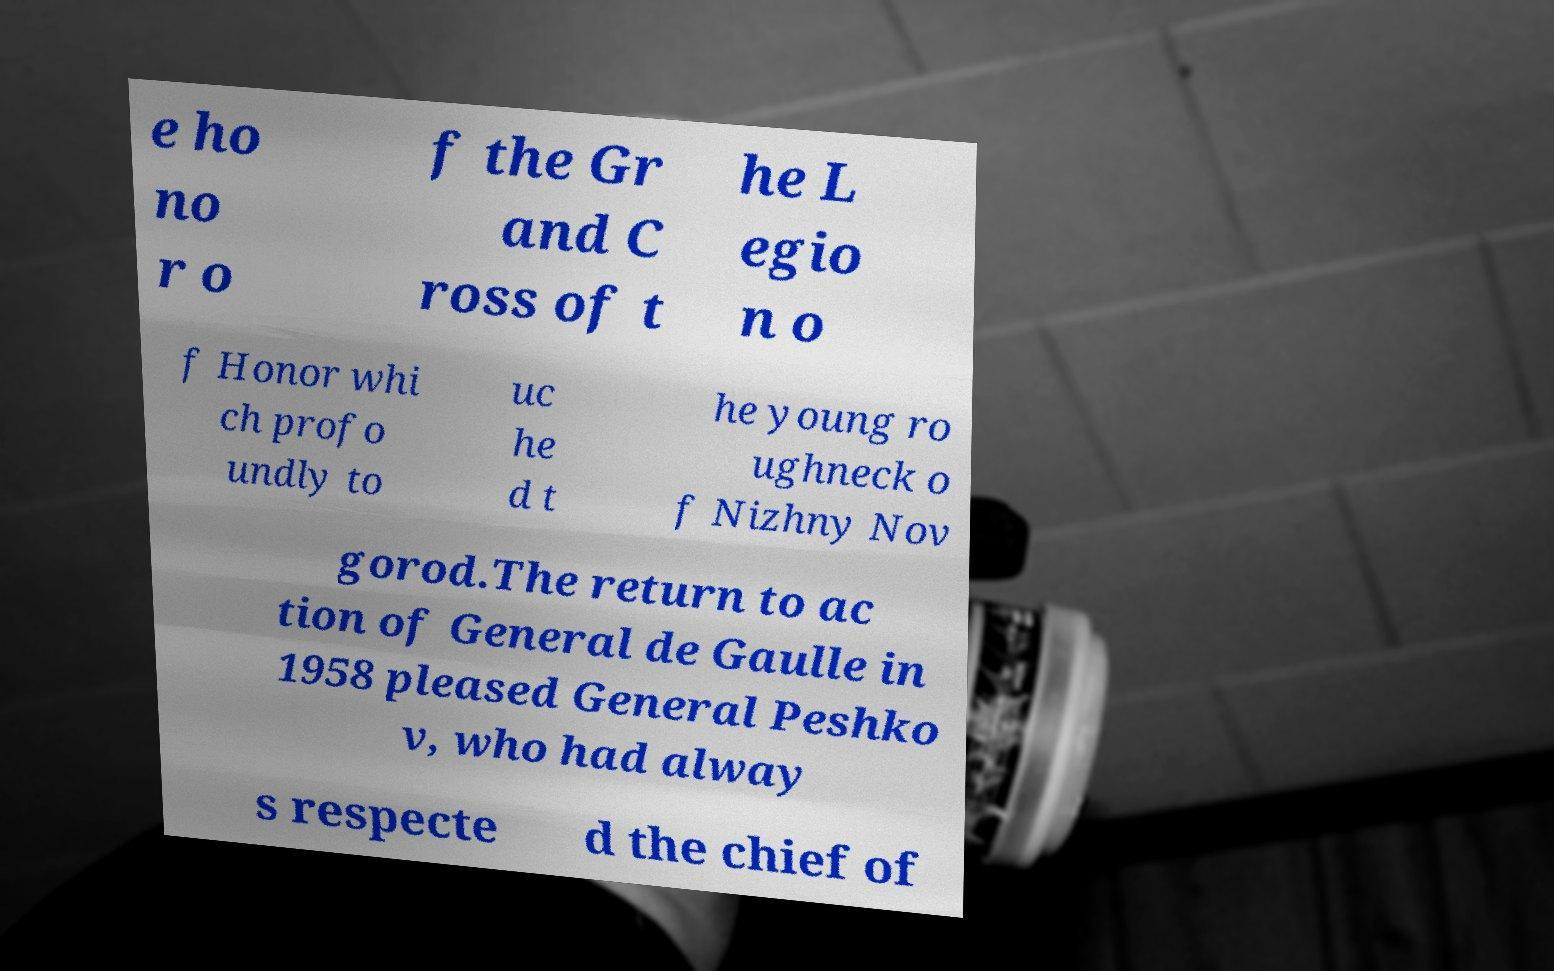Please identify and transcribe the text found in this image. e ho no r o f the Gr and C ross of t he L egio n o f Honor whi ch profo undly to uc he d t he young ro ughneck o f Nizhny Nov gorod.The return to ac tion of General de Gaulle in 1958 pleased General Peshko v, who had alway s respecte d the chief of 